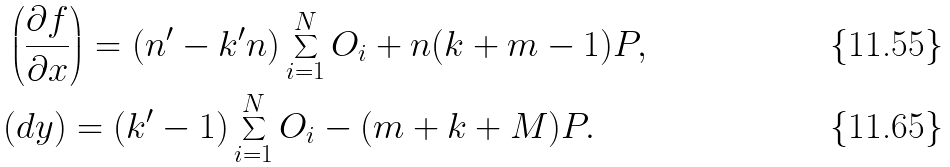<formula> <loc_0><loc_0><loc_500><loc_500>& \left ( \frac { \partial f } { \partial x } \right ) = ( n ^ { \prime } - k ^ { \prime } n ) \sum _ { i = 1 } ^ { N } O _ { i } + n ( k + m - 1 ) P , \\ & ( d y ) = ( k ^ { \prime } - 1 ) \sum _ { i = 1 } ^ { N } O _ { i } - ( m + k + M ) P .</formula> 